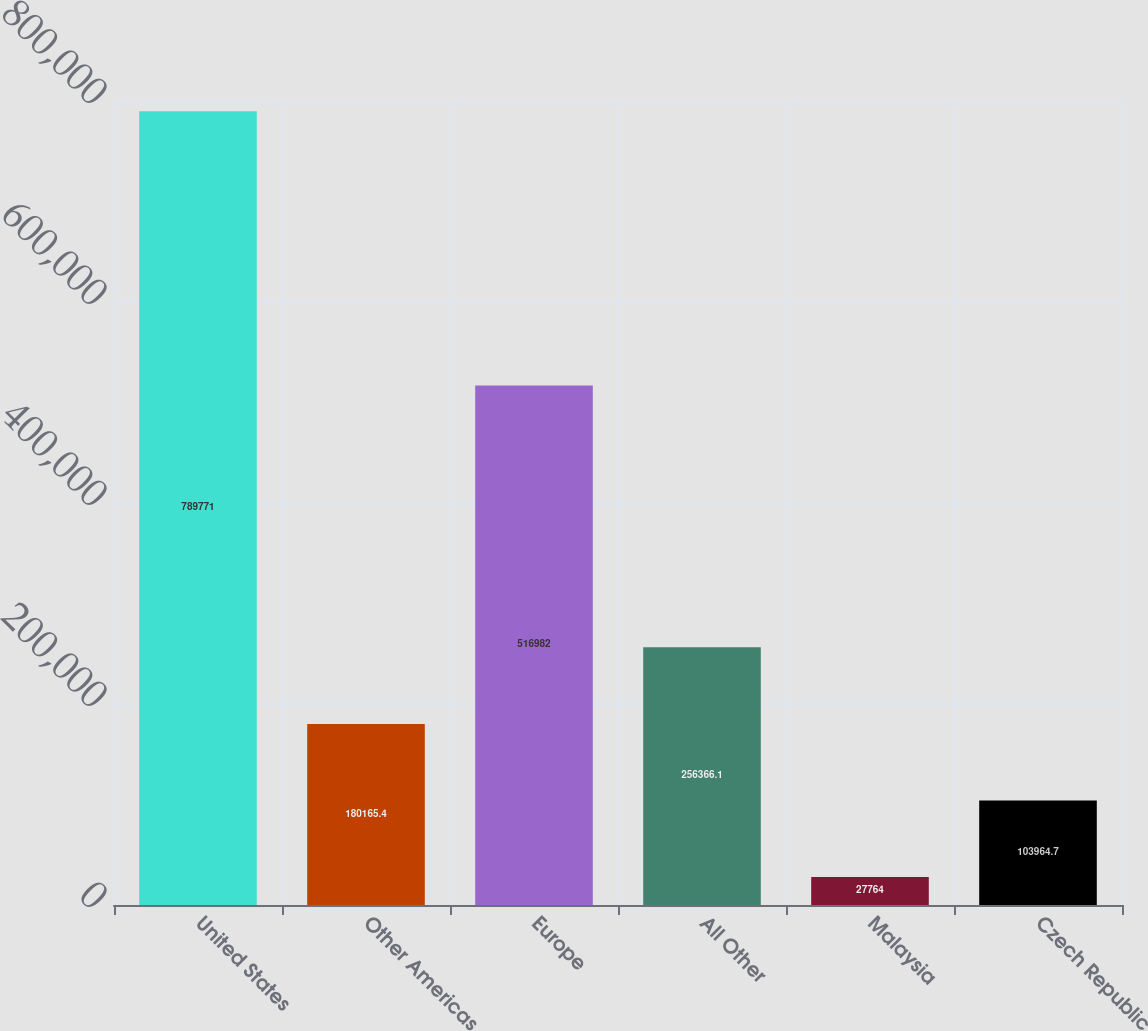<chart> <loc_0><loc_0><loc_500><loc_500><bar_chart><fcel>United States<fcel>Other Americas<fcel>Europe<fcel>All Other<fcel>Malaysia<fcel>Czech Republic<nl><fcel>789771<fcel>180165<fcel>516982<fcel>256366<fcel>27764<fcel>103965<nl></chart> 